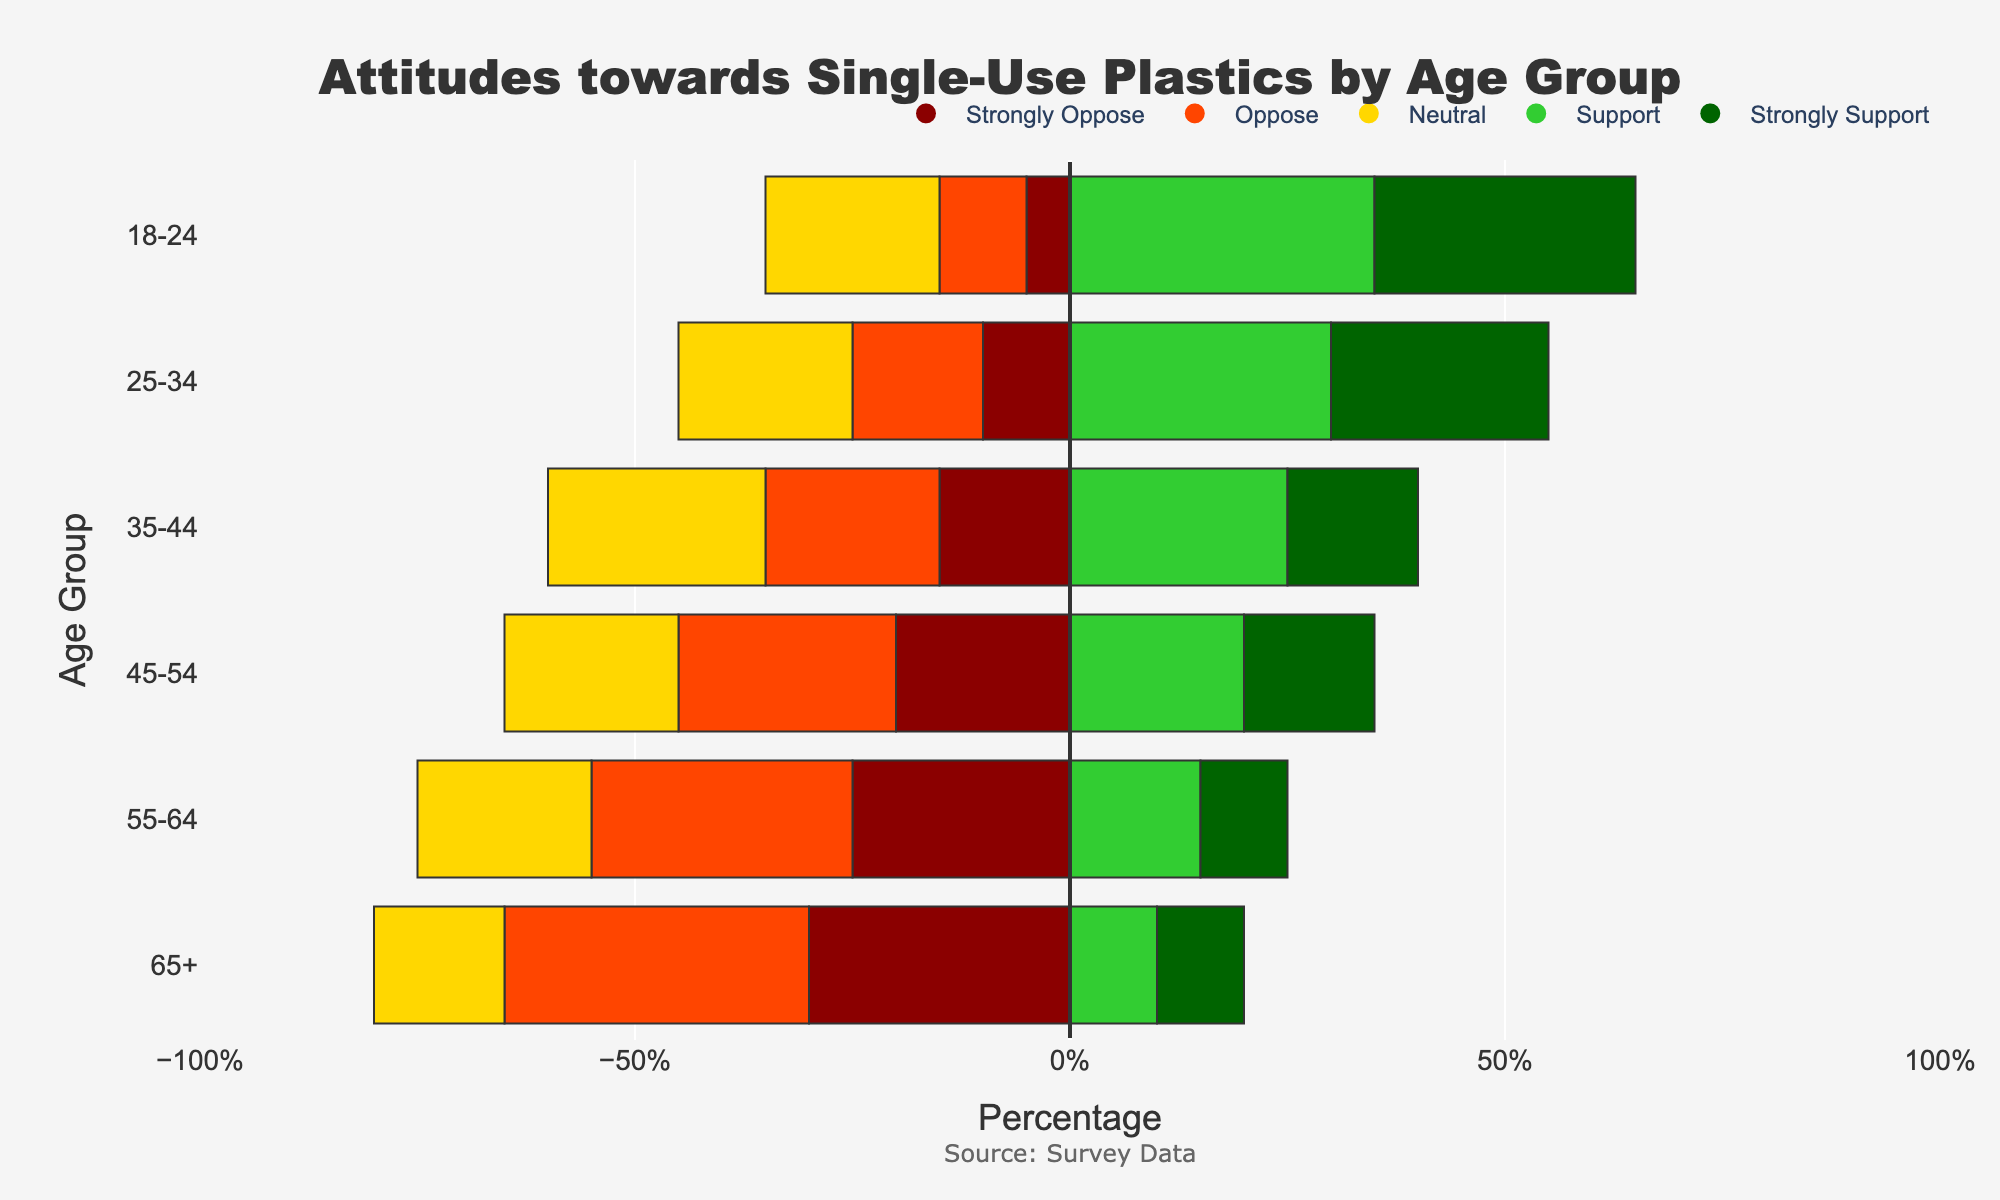What is the total opposition (both 'Strongly Oppose' and 'Oppose') percentage for the age group 18-24? Add 'Strongly Oppose' and 'Oppose' percentages for the 18-24 age group: 5% + 10% = 15%
Answer: 15% Which age group has the highest percentage of 'Strongly Support'? 'Strongly Support' percentages for all age groups: 18-24 (30%), 25-34 (25%), 35-44 (15%), 45-54 (15%), 55-64 (10%), 65+ (10%). The highest is 18-24 with 30%
Answer: 18-24 How does the percentage of 'Neutral' for the 35-44 age group compare to that of the 65+ age group? 'Neutral' percentages: 35-44 (25%), 65+ (15%). 35-44 is higher than 65+
Answer: 35-44 has a higher percentage Is 'Oppose' more common in the 45-54 age group or the 55-64 age group? 'Oppose' percentages: 45-54 (25%), 55-64 (30%). 55-64 is higher
Answer: 55-64 What is the sum of the 'Strongly Oppose' and 'Oppose' percentages for the age group 55-64? Add 'Strongly Oppose' and 'Oppose' percentages for the 55-64 age group: 25% + 30% = 55%
Answer: 55% What trend do you observe for 'Support' across increasing age groups? 'Support' percentages: 18-24 (35%), 25-34 (30%), 35-44 (25%), 45-54 (20%), 55-64 (15%), 65+ (10%). There is a decreasing trend
Answer: Decreasing Which age group has the lowest percentage of 'Strongly Oppose'? 'Strongly Oppose' percentages: 18-24 (5%), 25-34 (10%), 35-44 (15%), 45-54 (20%), 55-64 (25%), 65+ (30%). The lowest is 18-24 with 5%
Answer: 18-24 What is the difference between the 'Strongly Support' and 'Strongly Oppose' percentages for the 25-34 age group? 'Strongly Support' and 'Strongly Oppose' percentages for 25-34: 25% and 10%. Difference is 25% - 10% = 15%
Answer: 15% Which age group's bar extends the furthest to the right for 'Support'? 'Support' percentages: 18-24 (35%), 25-34 (30%), 35-44 (25%), 45-54 (20%), 55-64 (15%), 65+ (10%). The 18-24 group has the longest 'Support' bar
Answer: 18-24 